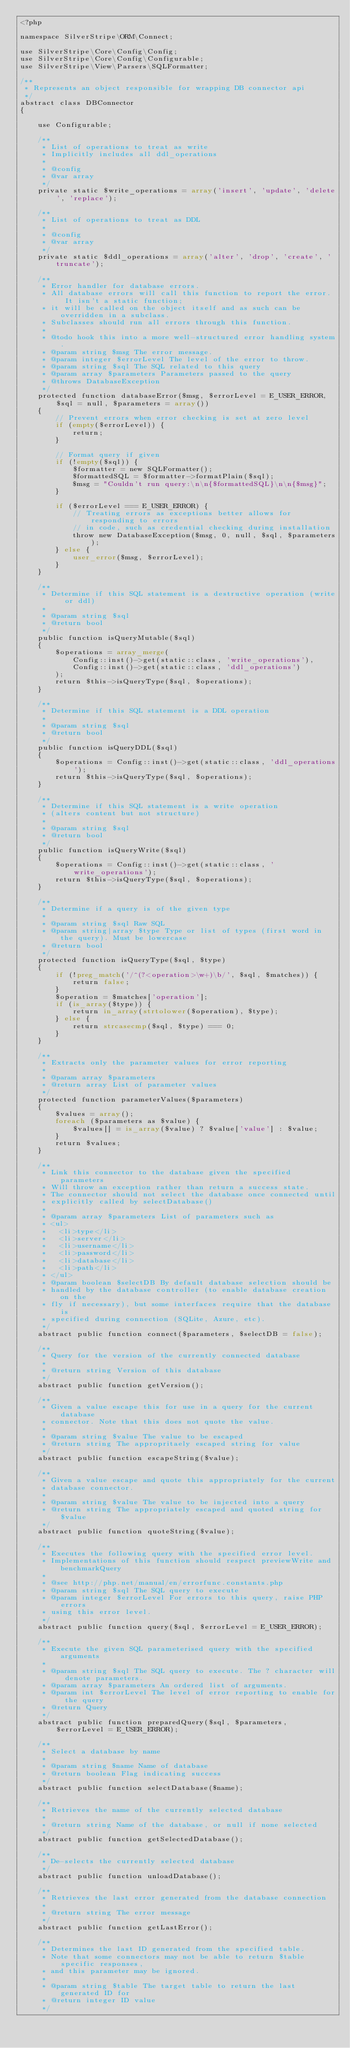Convert code to text. <code><loc_0><loc_0><loc_500><loc_500><_PHP_><?php

namespace SilverStripe\ORM\Connect;

use SilverStripe\Core\Config\Config;
use SilverStripe\Core\Config\Configurable;
use SilverStripe\View\Parsers\SQLFormatter;

/**
 * Represents an object responsible for wrapping DB connector api
 */
abstract class DBConnector
{

    use Configurable;

    /**
     * List of operations to treat as write
     * Implicitly includes all ddl_operations
     *
     * @config
     * @var array
     */
    private static $write_operations = array('insert', 'update', 'delete', 'replace');

    /**
     * List of operations to treat as DDL
     *
     * @config
     * @var array
     */
    private static $ddl_operations = array('alter', 'drop', 'create', 'truncate');

    /**
     * Error handler for database errors.
     * All database errors will call this function to report the error.  It isn't a static function;
     * it will be called on the object itself and as such can be overridden in a subclass.
     * Subclasses should run all errors through this function.
     *
     * @todo hook this into a more well-structured error handling system.
     * @param string $msg The error message.
     * @param integer $errorLevel The level of the error to throw.
     * @param string $sql The SQL related to this query
     * @param array $parameters Parameters passed to the query
     * @throws DatabaseException
     */
    protected function databaseError($msg, $errorLevel = E_USER_ERROR, $sql = null, $parameters = array())
    {
        // Prevent errors when error checking is set at zero level
        if (empty($errorLevel)) {
            return;
        }

        // Format query if given
        if (!empty($sql)) {
            $formatter = new SQLFormatter();
            $formattedSQL = $formatter->formatPlain($sql);
            $msg = "Couldn't run query:\n\n{$formattedSQL}\n\n{$msg}";
        }

        if ($errorLevel === E_USER_ERROR) {
            // Treating errors as exceptions better allows for responding to errors
            // in code, such as credential checking during installation
            throw new DatabaseException($msg, 0, null, $sql, $parameters);
        } else {
            user_error($msg, $errorLevel);
        }
    }

    /**
     * Determine if this SQL statement is a destructive operation (write or ddl)
     *
     * @param string $sql
     * @return bool
     */
    public function isQueryMutable($sql)
    {
        $operations = array_merge(
            Config::inst()->get(static::class, 'write_operations'),
            Config::inst()->get(static::class, 'ddl_operations')
        );
        return $this->isQueryType($sql, $operations);
    }

    /**
     * Determine if this SQL statement is a DDL operation
     *
     * @param string $sql
     * @return bool
     */
    public function isQueryDDL($sql)
    {
        $operations = Config::inst()->get(static::class, 'ddl_operations');
        return $this->isQueryType($sql, $operations);
    }

    /**
     * Determine if this SQL statement is a write operation
     * (alters content but not structure)
     *
     * @param string $sql
     * @return bool
     */
    public function isQueryWrite($sql)
    {
        $operations = Config::inst()->get(static::class, 'write_operations');
        return $this->isQueryType($sql, $operations);
    }

    /**
     * Determine if a query is of the given type
     *
     * @param string $sql Raw SQL
     * @param string|array $type Type or list of types (first word in the query). Must be lowercase
     * @return bool
     */
    protected function isQueryType($sql, $type)
    {
        if (!preg_match('/^(?<operation>\w+)\b/', $sql, $matches)) {
            return false;
        }
        $operation = $matches['operation'];
        if (is_array($type)) {
            return in_array(strtolower($operation), $type);
        } else {
            return strcasecmp($sql, $type) === 0;
        }
    }

    /**
     * Extracts only the parameter values for error reporting
     *
     * @param array $parameters
     * @return array List of parameter values
     */
    protected function parameterValues($parameters)
    {
        $values = array();
        foreach ($parameters as $value) {
            $values[] = is_array($value) ? $value['value'] : $value;
        }
        return $values;
    }

    /**
     * Link this connector to the database given the specified parameters
     * Will throw an exception rather than return a success state.
     * The connector should not select the database once connected until
     * explicitly called by selectDatabase()
     *
     * @param array $parameters List of parameters such as
     * <ul>
     *   <li>type</li>
     *   <li>server</li>
     *   <li>username</li>
     *   <li>password</li>
     *   <li>database</li>
     *   <li>path</li>
     * </ul>
     * @param boolean $selectDB By default database selection should be
     * handled by the database controller (to enable database creation on the
     * fly if necessary), but some interfaces require that the database is
     * specified during connection (SQLite, Azure, etc).
     */
    abstract public function connect($parameters, $selectDB = false);

    /**
     * Query for the version of the currently connected database
     *
     * @return string Version of this database
     */
    abstract public function getVersion();

    /**
     * Given a value escape this for use in a query for the current database
     * connector. Note that this does not quote the value.
     *
     * @param string $value The value to be escaped
     * @return string The appropritaely escaped string for value
     */
    abstract public function escapeString($value);

    /**
     * Given a value escape and quote this appropriately for the current
     * database connector.
     *
     * @param string $value The value to be injected into a query
     * @return string The appropriately escaped and quoted string for $value
     */
    abstract public function quoteString($value);

    /**
     * Executes the following query with the specified error level.
     * Implementations of this function should respect previewWrite and benchmarkQuery
     *
     * @see http://php.net/manual/en/errorfunc.constants.php
     * @param string $sql The SQL query to execute
     * @param integer $errorLevel For errors to this query, raise PHP errors
     * using this error level.
     */
    abstract public function query($sql, $errorLevel = E_USER_ERROR);

    /**
     * Execute the given SQL parameterised query with the specified arguments
     *
     * @param string $sql The SQL query to execute. The ? character will denote parameters.
     * @param array $parameters An ordered list of arguments.
     * @param int $errorLevel The level of error reporting to enable for the query
     * @return Query
     */
    abstract public function preparedQuery($sql, $parameters, $errorLevel = E_USER_ERROR);

    /**
     * Select a database by name
     *
     * @param string $name Name of database
     * @return boolean Flag indicating success
     */
    abstract public function selectDatabase($name);

    /**
     * Retrieves the name of the currently selected database
     *
     * @return string Name of the database, or null if none selected
     */
    abstract public function getSelectedDatabase();

    /**
     * De-selects the currently selected database
     */
    abstract public function unloadDatabase();

    /**
     * Retrieves the last error generated from the database connection
     *
     * @return string The error message
     */
    abstract public function getLastError();

    /**
     * Determines the last ID generated from the specified table.
     * Note that some connectors may not be able to return $table specific responses,
     * and this parameter may be ignored.
     *
     * @param string $table The target table to return the last generated ID for
     * @return integer ID value
     */</code> 